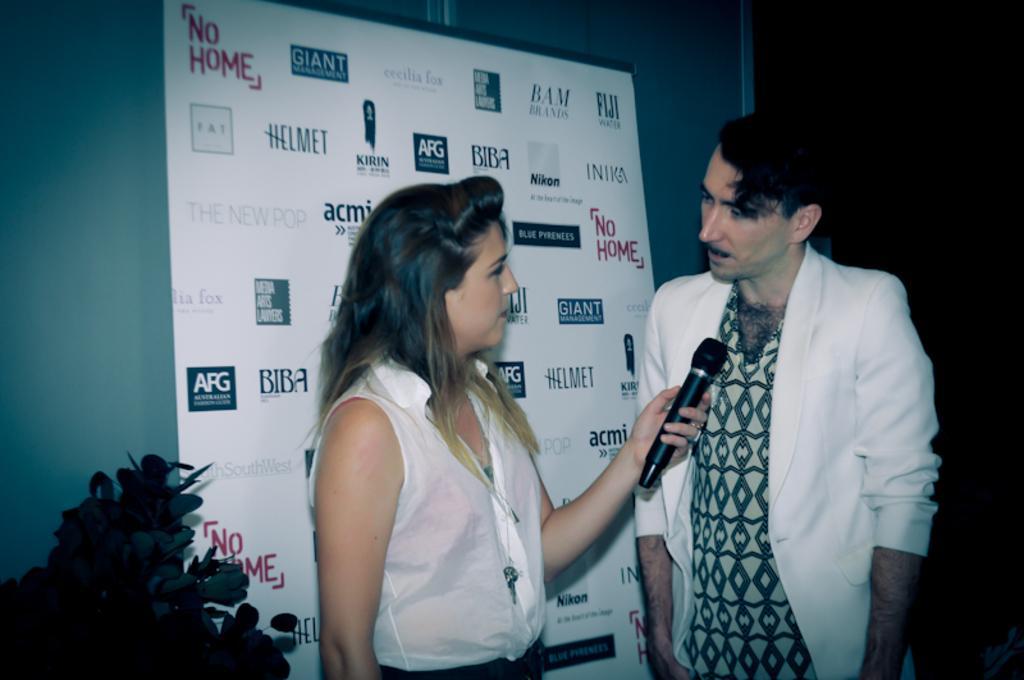Please provide a concise description of this image. In this picture there are two people standing on the floor. The women in white dress holding the microphone on the man in white shirt is looking the women. Background of this people there is a banner. The banner is in white color. 